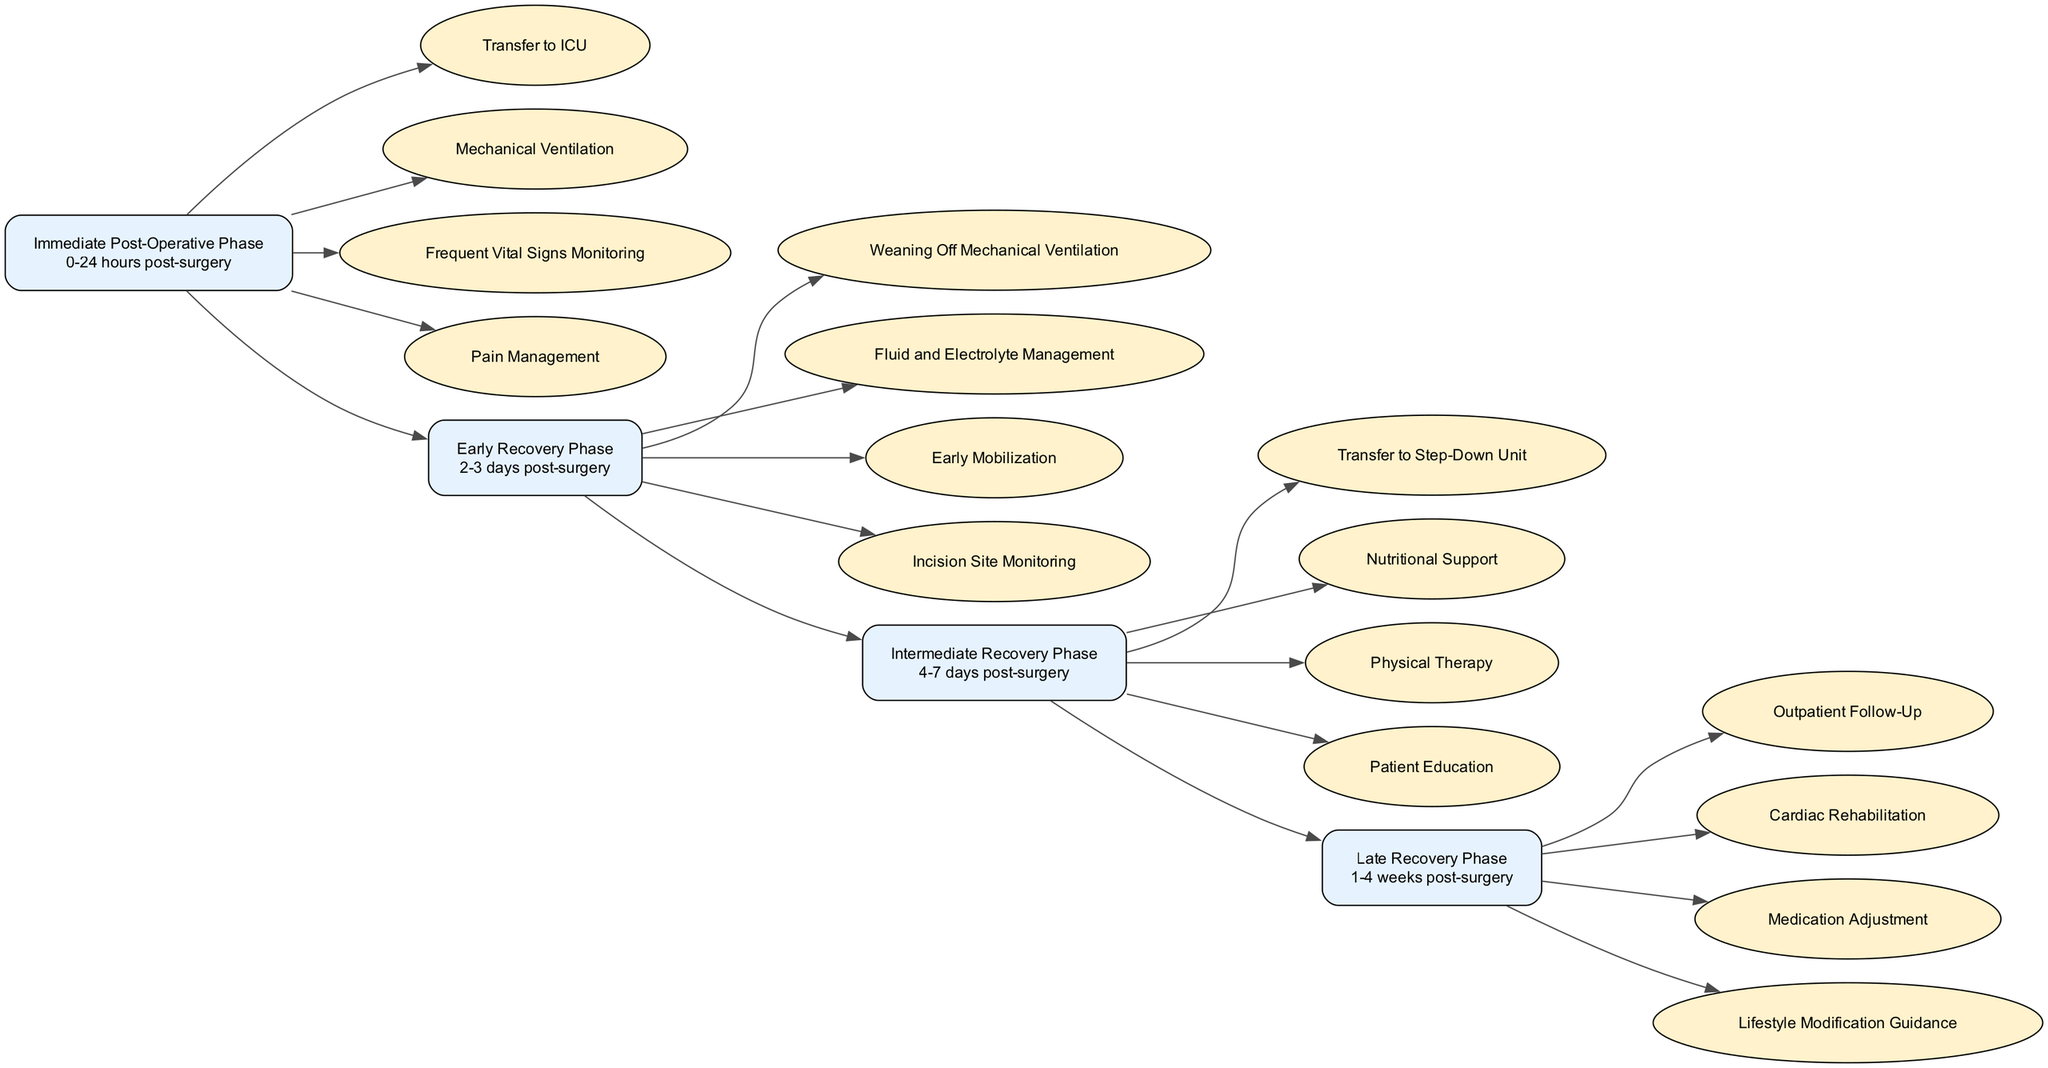What is the first milestone in the Post-Operative Care Pathway? The first milestone listed in the diagram is "Immediate Post-Operative Phase"
Answer: Immediate Post-Operative Phase How many checkpoints are in the Intermediate Recovery Phase? The Intermediate Recovery Phase has four checkpoints listed, which are associated with that milestone
Answer: 4 What is the duration of the Early Recovery Phase? The duration indicated for the Early Recovery Phase is "2-3 days post-surgery"
Answer: 2-3 days What milestone follows the Late Recovery Phase? In the diagram, there are no milestones listed after the Late Recovery Phase, indicating it is the final phase of the pathway
Answer: None Which checkpoint is associated with the Immediate Post-Operative Phase? One checkpoint from the Immediate Post-Operative Phase is "Mechanical Ventilation"
Answer: Mechanical Ventilation How many milestones are in the Post-Operative Care Pathway? The pathway contains a total of four milestones, outlined from the Immediate to Late Recovery Phases
Answer: 4 What are the two pathways connecting Early Recovery and Intermediate Recovery? The two milestones connecting Early Recovery and Intermediate Recovery are "Early Recovery Phase" and "Intermediate Recovery Phase"
Answer: Early Recovery Phase, Intermediate Recovery Phase What type of support is emphasized in the Intermediate Recovery Phase? "Nutritional Support" is specifically mentioned as a key focus during the Intermediate Recovery Phase
Answer: Nutritional Support Identify the milestone associated with outpatient follow-up. The milestone related to outpatient follow-up is "Late Recovery Phase"
Answer: Late Recovery Phase 